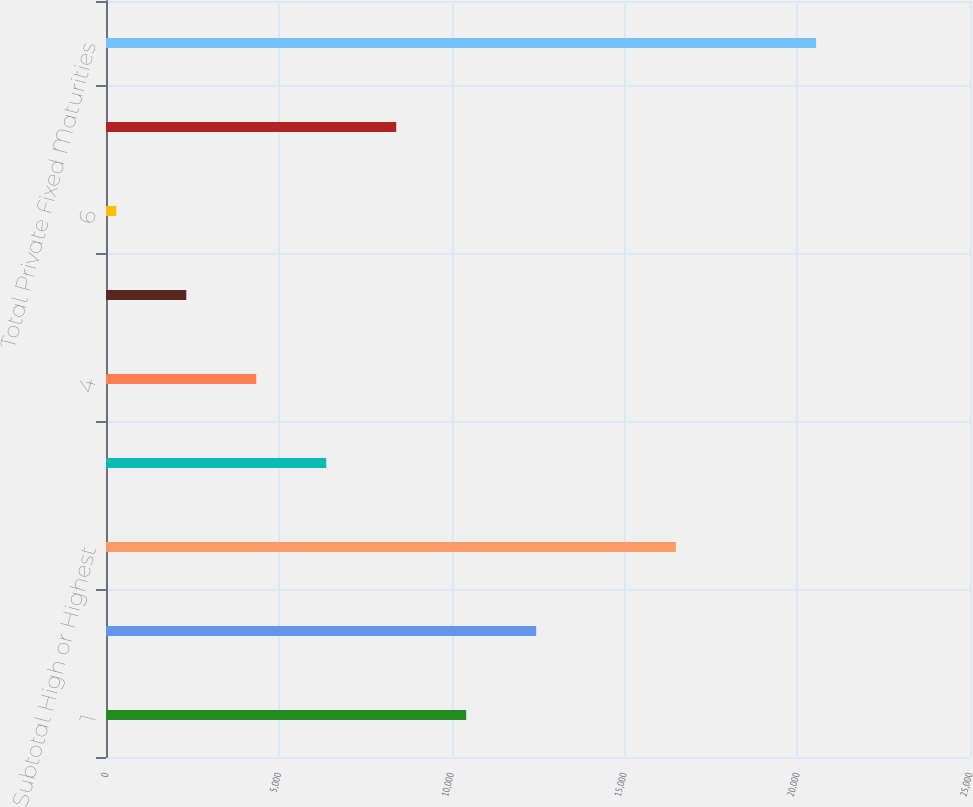Convert chart. <chart><loc_0><loc_0><loc_500><loc_500><bar_chart><fcel>1<fcel>2<fcel>Subtotal High or Highest<fcel>3<fcel>4<fcel>5<fcel>6<fcel>Subtotal Other Securities(4)<fcel>Total Private Fixed Maturities<nl><fcel>10422.5<fcel>12447.4<fcel>16491<fcel>6372.7<fcel>4347.8<fcel>2322.9<fcel>298<fcel>8397.6<fcel>20547<nl></chart> 